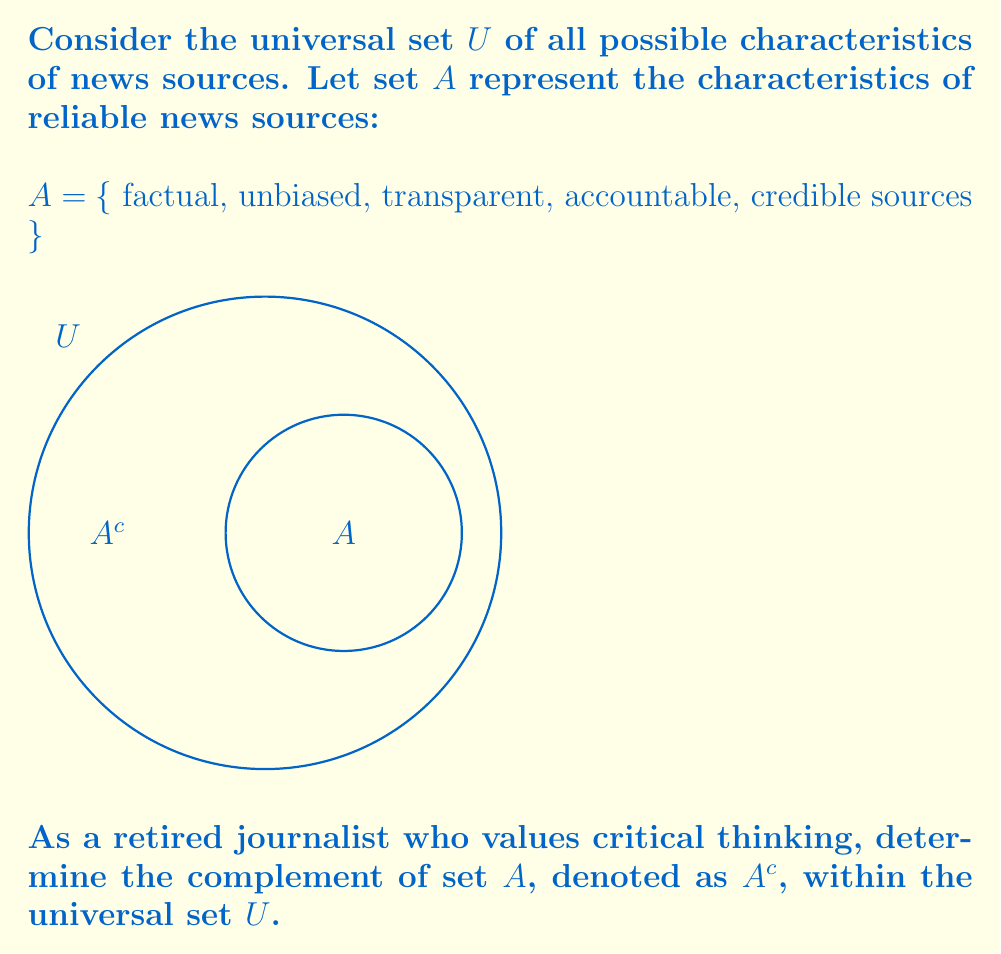Can you solve this math problem? To solve this problem, we need to understand the concept of set complement and apply it to the given set $A$. Let's break it down step-by-step:

1) The complement of a set $A$, denoted as $A^c$, is the set of all elements in the universal set $U$ that are not in $A$.

2) Mathematically, we can express this as:
   $A^c = U \setminus A$ (read as "U minus A")

3) In this case, $A^c$ will contain all characteristics of news sources that are not considered reliable.

4) To determine $A^c$, we need to consider the opposite or absence of each characteristic in set $A$:

   - Opposite of factual: non-factual or opinionated
   - Opposite of unbiased: biased
   - Opposite of transparent: opaque or secretive
   - Opposite of accountable: unaccountable
   - Opposite of credible sources: unreliable or questionable sources

5) Additionally, $A^c$ may include other characteristics not mentioned in $A$ that are not associated with reliable news sources, such as:

   - Sensationalism
   - Clickbait
   - Lack of context
   - Anonymous sources

Therefore, $A^c$ is the set of all these characteristics that are not associated with reliable news sources.
Answer: $A^c = \{$ non-factual, biased, opaque, unaccountable, unreliable sources, sensationalism, clickbait, lack of context, anonymous sources $\}$ 